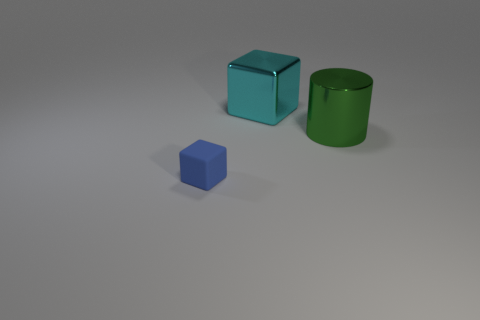Add 2 big cyan rubber cylinders. How many objects exist? 5 Subtract all blocks. How many objects are left? 1 Add 3 large metallic cylinders. How many large metallic cylinders are left? 4 Add 3 small objects. How many small objects exist? 4 Subtract 0 yellow cylinders. How many objects are left? 3 Subtract all cyan metal cubes. Subtract all cyan metallic blocks. How many objects are left? 1 